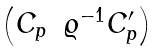Convert formula to latex. <formula><loc_0><loc_0><loc_500><loc_500>\begin{pmatrix} C _ { p } & \varrho ^ { - 1 } C _ { p } ^ { \prime } \end{pmatrix}</formula> 